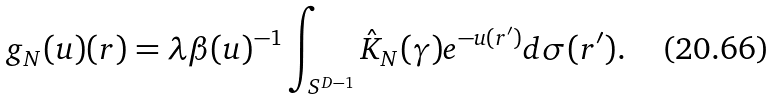<formula> <loc_0><loc_0><loc_500><loc_500>g _ { N } ( u ) ( r ) = \lambda \beta ( u ) ^ { - 1 } \int _ { S ^ { D - 1 } } \hat { K } _ { N } ( \gamma ) e ^ { - u ( r ^ { \prime } ) } d \sigma ( r ^ { \prime } ) .</formula> 